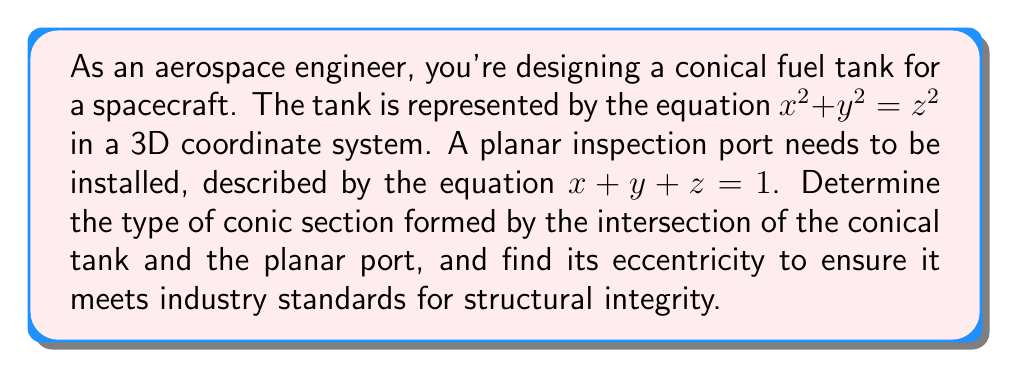Give your solution to this math problem. 1) The conical surface is given by $x^2 + y^2 = z^2$, and the plane by $x + y + z = 1$.

2) To find the intersection, we need to solve these equations simultaneously. Substitute $z = 1 - x - y$ from the plane equation into the cone equation:

   $x^2 + y^2 = (1 - x - y)^2$

3) Expand the right side:
   $x^2 + y^2 = 1 - 2x - 2y + x^2 + 2xy + y^2$

4) Simplify:
   $0 = 1 - 2x - 2y + 2xy$

5) Rearrange:
   $2xy - 2x - 2y + 1 = 0$

6) This is the general form of a hyperbola equation.

7) To find the eccentricity, we need to transform this to standard form. First, rotate the axes by 45° using the substitution:
   $x = \frac{X - Y}{\sqrt{2}}$, $y = \frac{X + Y}{\sqrt{2}}$

8) After substitution and simplification, we get:
   $X^2 - Y^2 = \frac{1}{2}$

9) This is the standard form of a hyperbola centered at the origin with $a^2 = \frac{1}{2}$ and $b^2 = \frac{1}{2}$.

10) The eccentricity of a hyperbola is given by $e = \sqrt{1 + \frac{b^2}{a^2}}$.

11) Substituting our values:
    $e = \sqrt{1 + \frac{\frac{1}{2}}{\frac{1}{2}}} = \sqrt{2} \approx 1.414$
Answer: Hyperbola with eccentricity $\sqrt{2}$ 